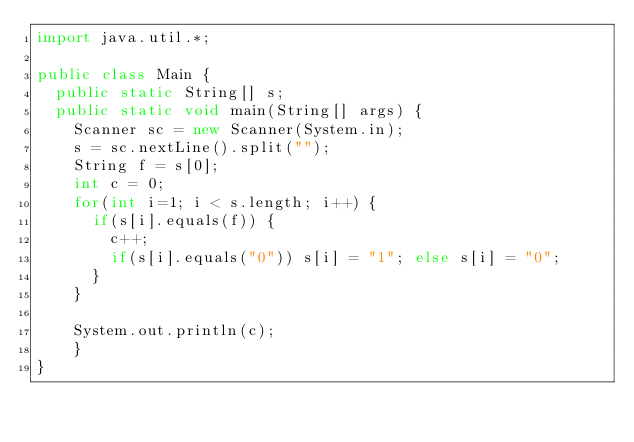Convert code to text. <code><loc_0><loc_0><loc_500><loc_500><_Java_>import java.util.*;

public class Main {
	public static String[] s;
	public static void main(String[] args) {
		Scanner sc = new Scanner(System.in);
		s = sc.nextLine().split("");
		String f = s[0];
		int c = 0;
		for(int i=1; i < s.length; i++) {
			if(s[i].equals(f)) {
				c++;
				if(s[i].equals("0")) s[i] = "1"; else s[i] = "0";
			}
		}
		
		System.out.println(c);
	  }
}</code> 